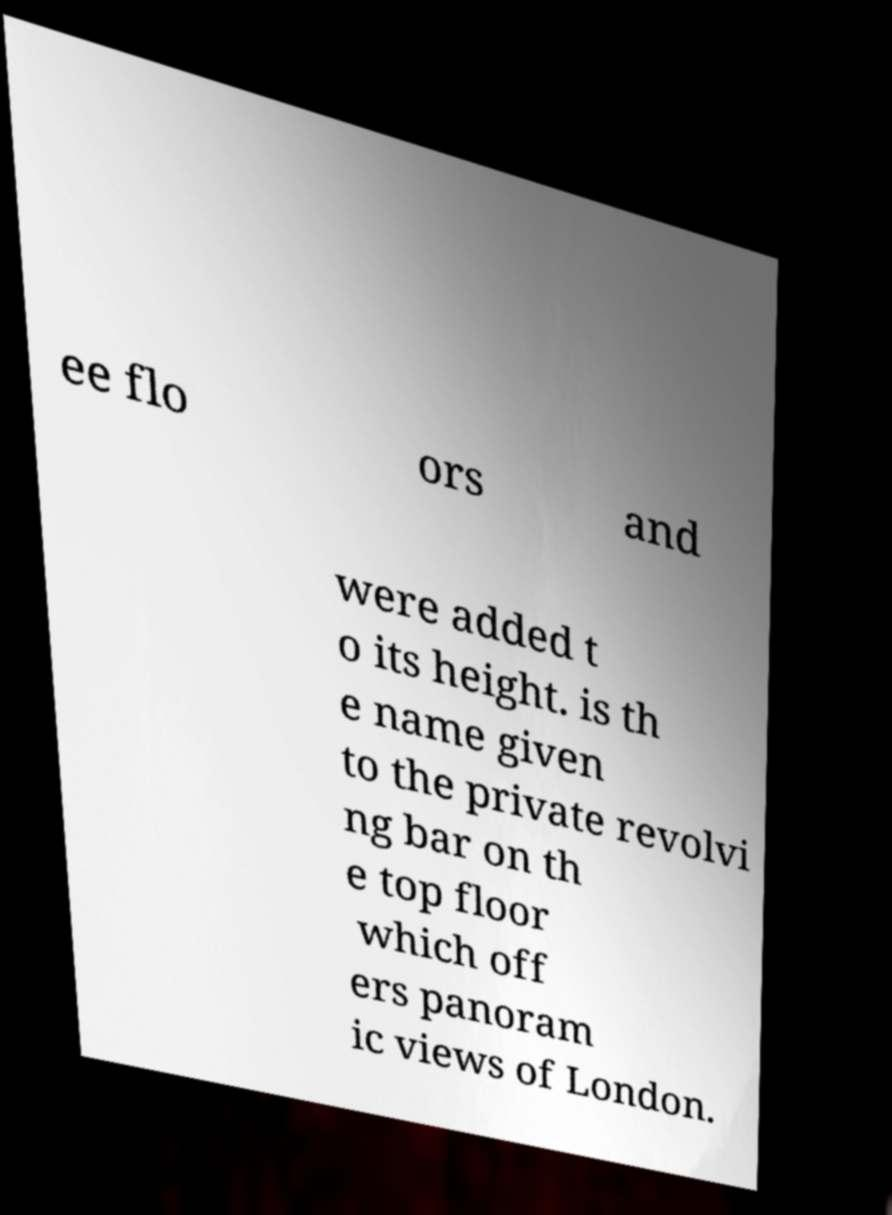Could you assist in decoding the text presented in this image and type it out clearly? ee flo ors and were added t o its height. is th e name given to the private revolvi ng bar on th e top floor which off ers panoram ic views of London. 